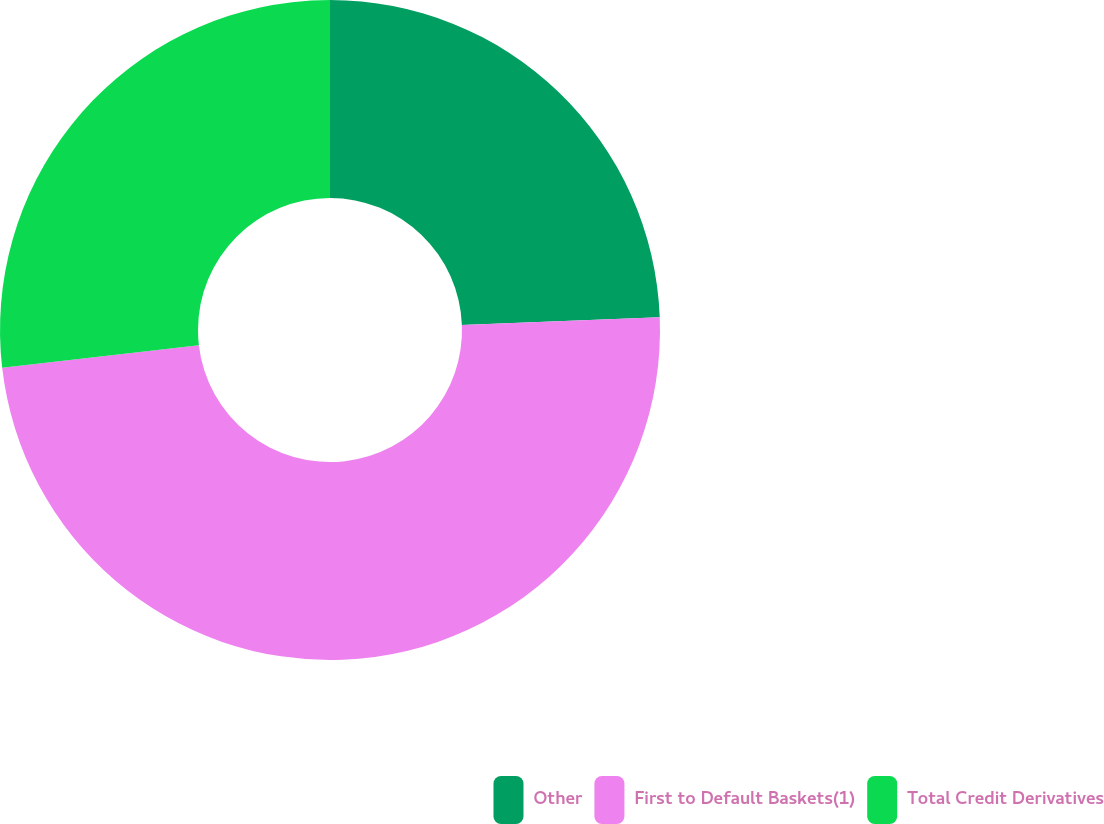Convert chart. <chart><loc_0><loc_0><loc_500><loc_500><pie_chart><fcel>Other<fcel>First to Default Baskets(1)<fcel>Total Credit Derivatives<nl><fcel>24.39%<fcel>48.78%<fcel>26.83%<nl></chart> 